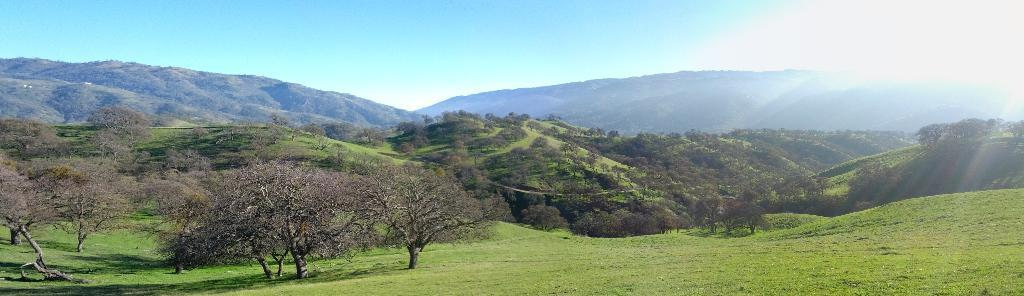What type of vegetation can be seen in the image? There are trees in the image. What else can be seen on the ground in the image? There is grass in the image. What type of landscape feature is present in the image? There are hills in the image. What is visible in the background of the image? The sky is visible in the image. Can you tell me where the crime is taking place in the image? There is no crime present in the image; it features trees, grass, hills, and the sky. What type of bird's nest can be seen in the image? There is no bird's nest present in the image. 